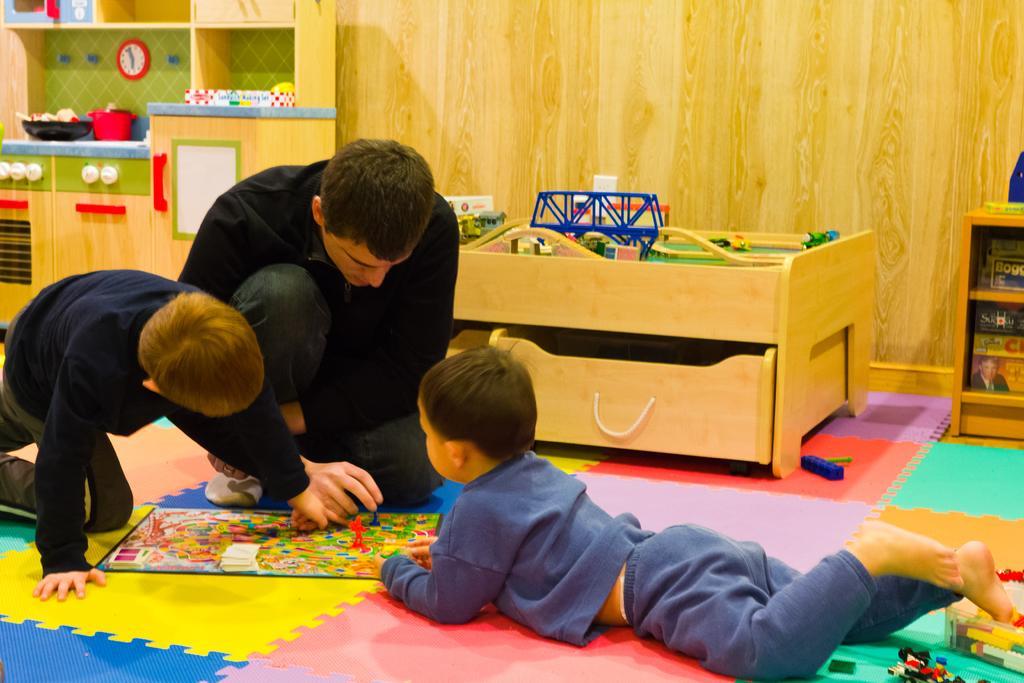How would you summarize this image in a sentence or two? In this image I can see in the middle a boy is lying on the floor, on the left side two persons are playing the game. At the back side it looks like a wooden wall. 